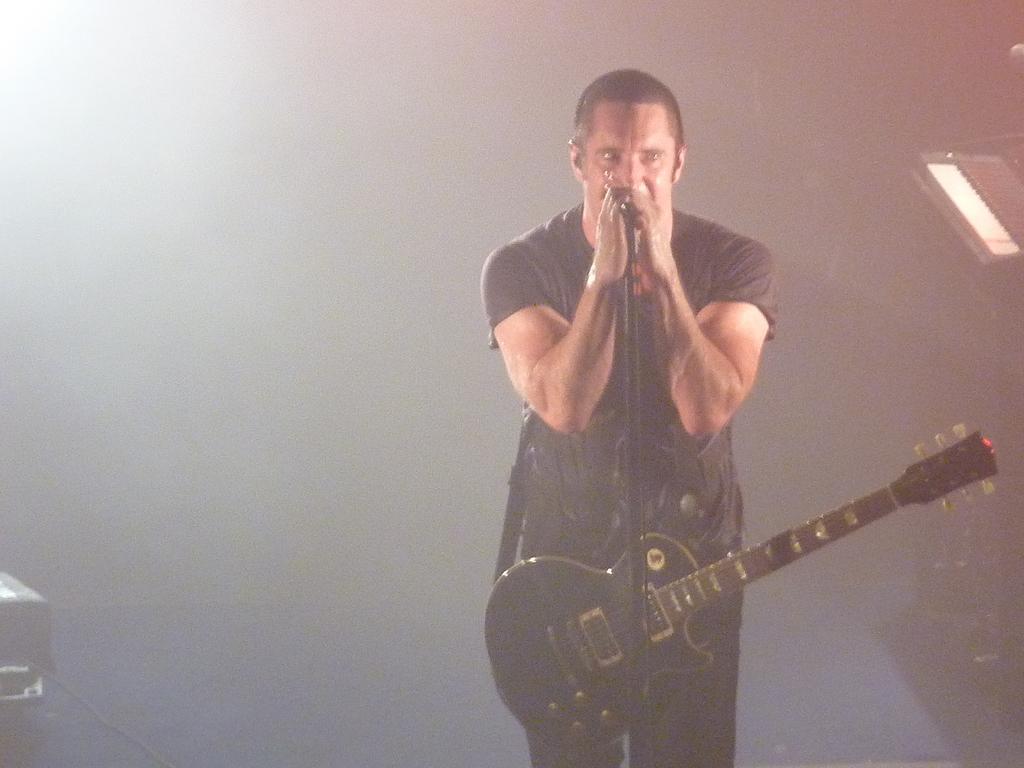In one or two sentences, can you explain what this image depicts? A man with black t-shirt is standing holding a mic in his hand and is wearing guitar. To left corner there is a black box with wire. And to the right top corner there is a piano. 